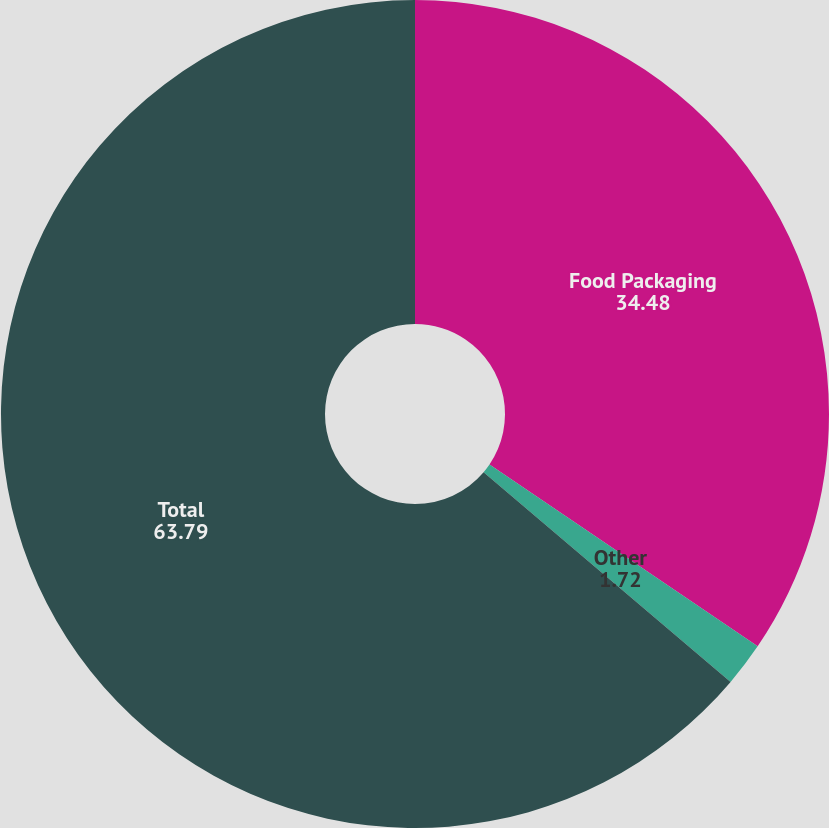Convert chart to OTSL. <chart><loc_0><loc_0><loc_500><loc_500><pie_chart><fcel>Food Packaging<fcel>Other<fcel>Total<nl><fcel>34.48%<fcel>1.72%<fcel>63.79%<nl></chart> 